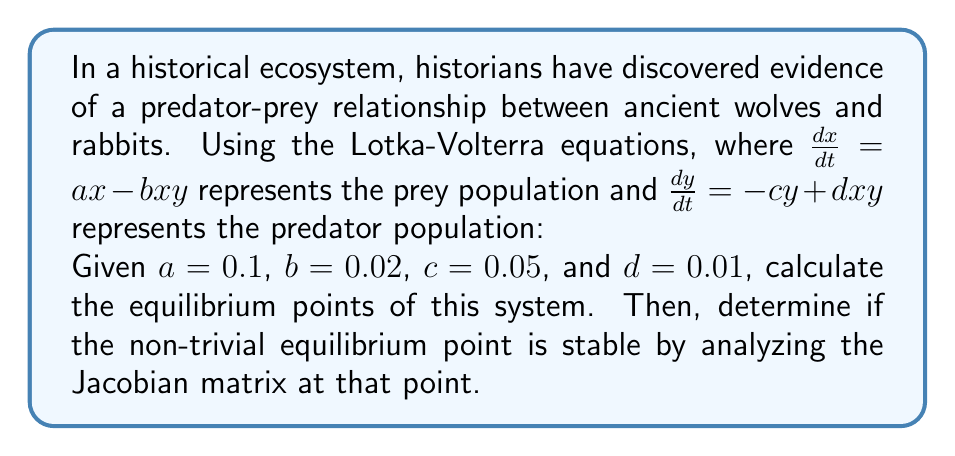Could you help me with this problem? To solve this problem, we'll follow these steps:

1. Find the equilibrium points:
   Set $\frac{dx}{dt} = 0$ and $\frac{dy}{dt} = 0$, then solve for x and y.

   For $\frac{dx}{dt} = 0$:
   $0 = ax - bxy$
   $x(a - by) = 0$
   So, either $x = 0$ or $y = \frac{a}{b}$

   For $\frac{dy}{dt} = 0$:
   $0 = -cy + dxy$
   $y(-c + dx) = 0$
   So, either $y = 0$ or $x = \frac{c}{d}$

   Equilibrium points are (0, 0) and $(\frac{c}{d}, \frac{a}{b})$

2. Calculate the non-trivial equilibrium point:
   $x^* = \frac{c}{d} = \frac{0.05}{0.01} = 5$
   $y^* = \frac{a}{b} = \frac{0.1}{0.02} = 5$

3. Construct the Jacobian matrix:
   $J = \begin{bmatrix}
   \frac{\partial}{\partial x}(ax - bxy) & \frac{\partial}{\partial y}(ax - bxy) \\
   \frac{\partial}{\partial x}(-cy + dxy) & \frac{\partial}{\partial y}(-cy + dxy)
   \end{bmatrix}$

   $J = \begin{bmatrix}
   a - by & -bx \\
   dy & -c + dx
   \end{bmatrix}$

4. Evaluate the Jacobian at the non-trivial equilibrium point (5, 5):
   $J(5,5) = \begin{bmatrix}
   0.1 - 0.02(5) & -0.02(5) \\
   0.01(5) & -0.05 + 0.01(5)
   \end{bmatrix} = \begin{bmatrix}
   0 & -0.1 \\
   0.05 & 0
   \end{bmatrix}$

5. Calculate the eigenvalues of J(5,5):
   $det(J - \lambda I) = \begin{vmatrix}
   -\lambda & -0.1 \\
   0.05 & -\lambda
   \end{vmatrix} = \lambda^2 + 0.005 = 0$

   $\lambda = \pm i\sqrt{0.005} \approx \pm 0.0707i$

6. Analyze stability:
   Since the real parts of both eigenvalues are zero, the equilibrium point is neutrally stable. This means that the system will exhibit periodic oscillations around this point.
Answer: The equilibrium points are (0, 0) and (5, 5). The non-trivial equilibrium point (5, 5) is neutrally stable, as the eigenvalues of the Jacobian matrix at this point are purely imaginary: $\lambda \approx \pm 0.0707i$. 